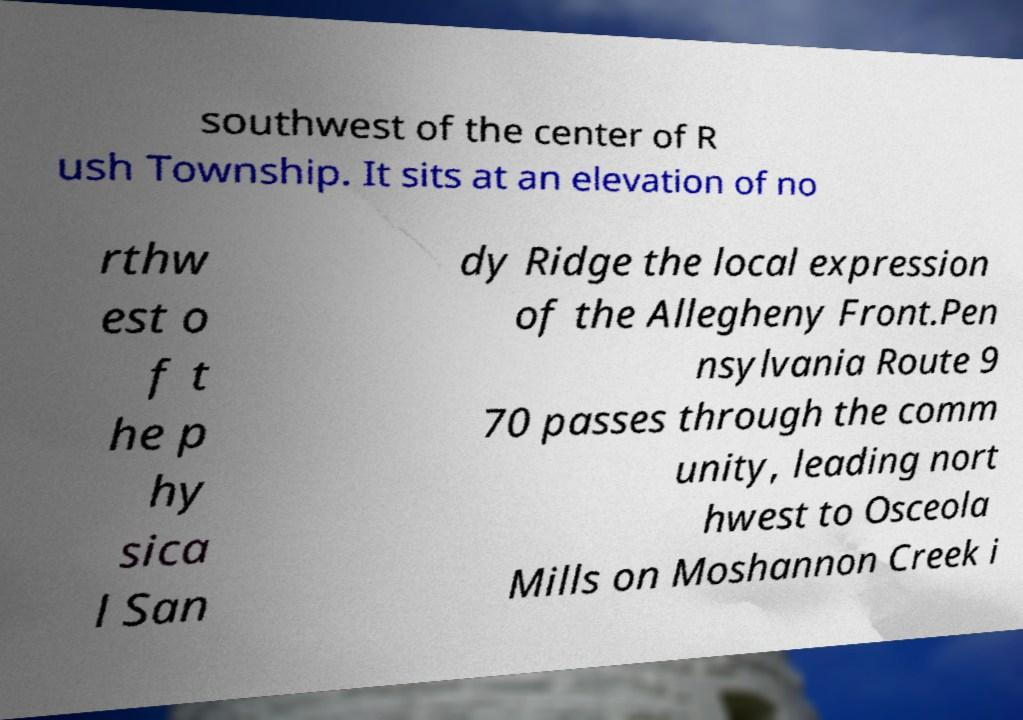Could you extract and type out the text from this image? southwest of the center of R ush Township. It sits at an elevation of no rthw est o f t he p hy sica l San dy Ridge the local expression of the Allegheny Front.Pen nsylvania Route 9 70 passes through the comm unity, leading nort hwest to Osceola Mills on Moshannon Creek i 